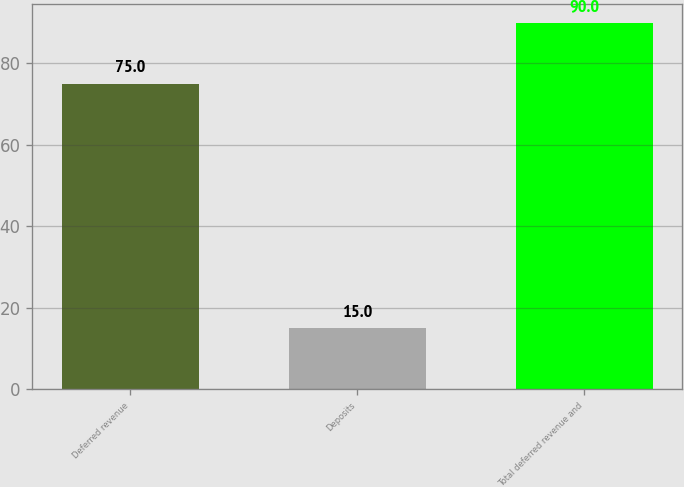Convert chart. <chart><loc_0><loc_0><loc_500><loc_500><bar_chart><fcel>Deferred revenue<fcel>Deposits<fcel>Total deferred revenue and<nl><fcel>75<fcel>15<fcel>90<nl></chart> 